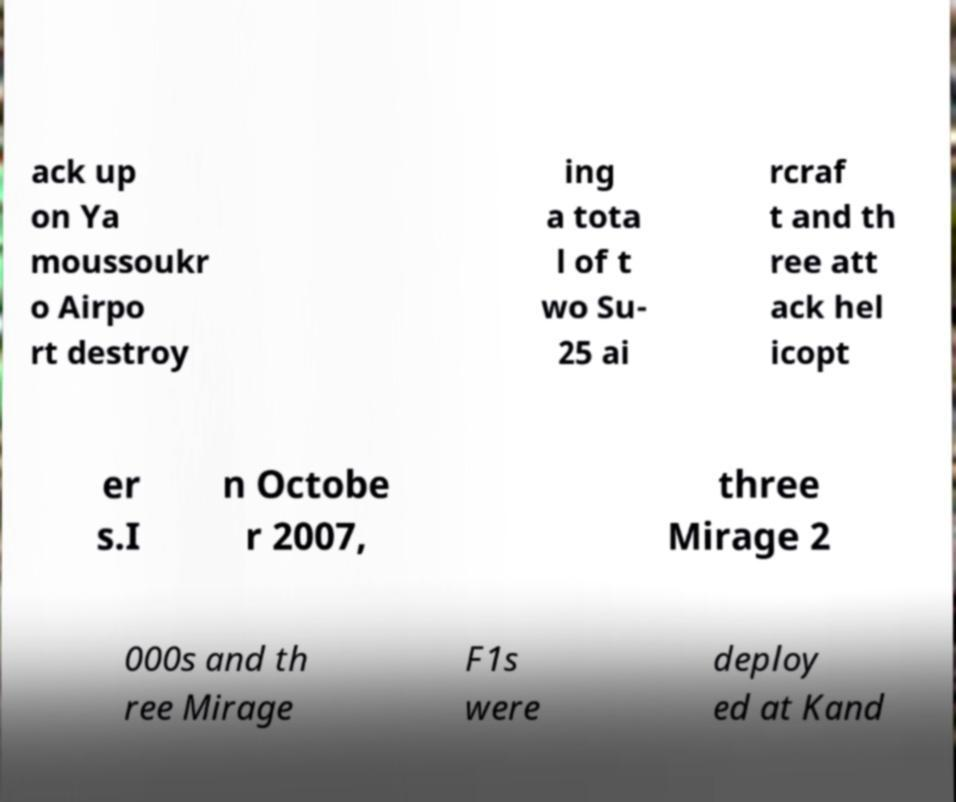I need the written content from this picture converted into text. Can you do that? ack up on Ya moussoukr o Airpo rt destroy ing a tota l of t wo Su- 25 ai rcraf t and th ree att ack hel icopt er s.I n Octobe r 2007, three Mirage 2 000s and th ree Mirage F1s were deploy ed at Kand 